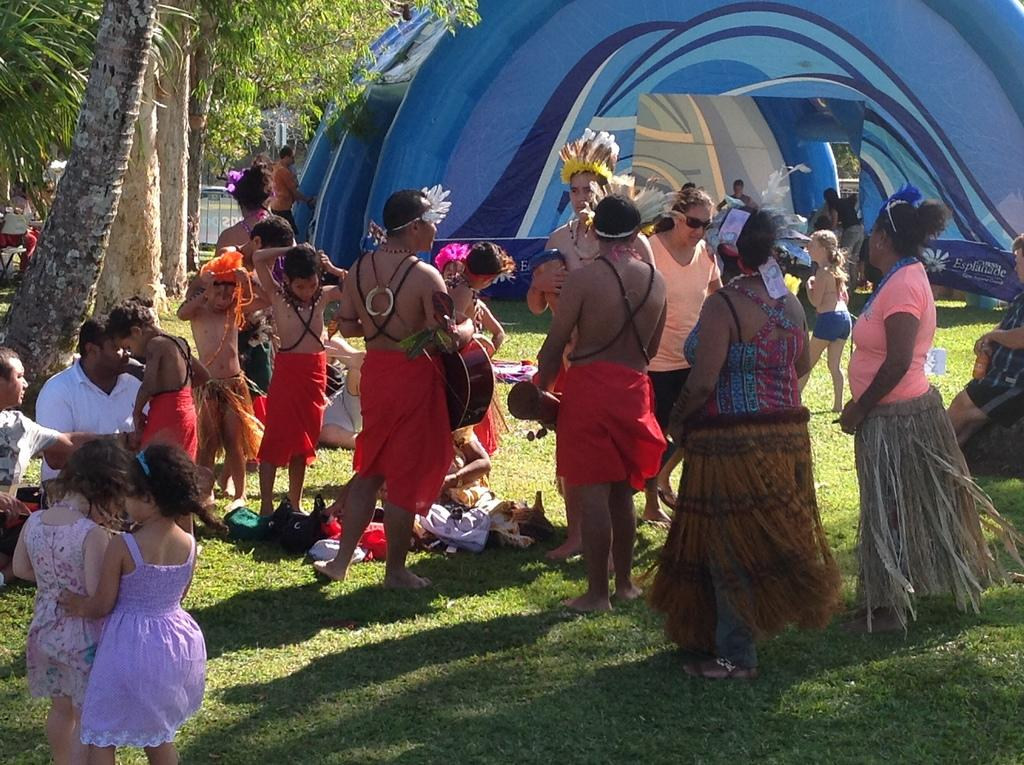What are the people in the image doing? There are persons standing and sitting on the grass in the image. What can be seen in the background of the image? There is a tent, an iron grill, and trees in the background of the image. What type of rod is being used to create bubbles in the image? There is no rod or bubbles present in the image. What kind of drug can be seen in the image? There is no drug present in the image. 